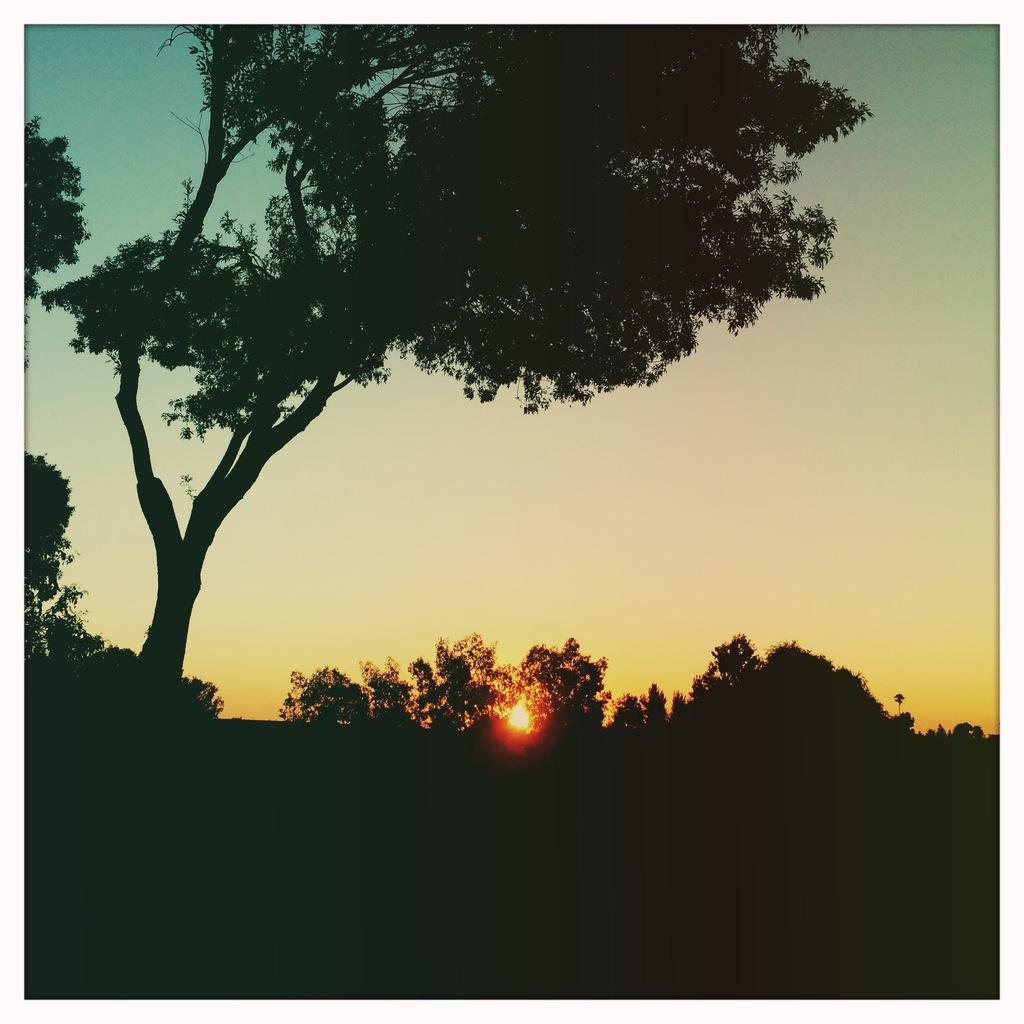What is located in the middle of the image? The sun is visible in the middle of the image, and there are trees as well. What can be seen on the left side of the image? There are trees on the left side of the image. What is the color of the bottom part of the image? The bottom part of the image is black in color. What is visible in the background of the image? The sky is visible in the background of the image. What theory is being proposed by the trees in the image? There is no theory being proposed by the trees in the image; they are simply trees. Are there any slaves depicted in the image? There is no mention of slaves or any related context in the image. 